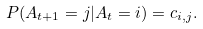Convert formula to latex. <formula><loc_0><loc_0><loc_500><loc_500>P ( A _ { t + 1 } = j | A _ { t } = i ) = c _ { i , j } .</formula> 